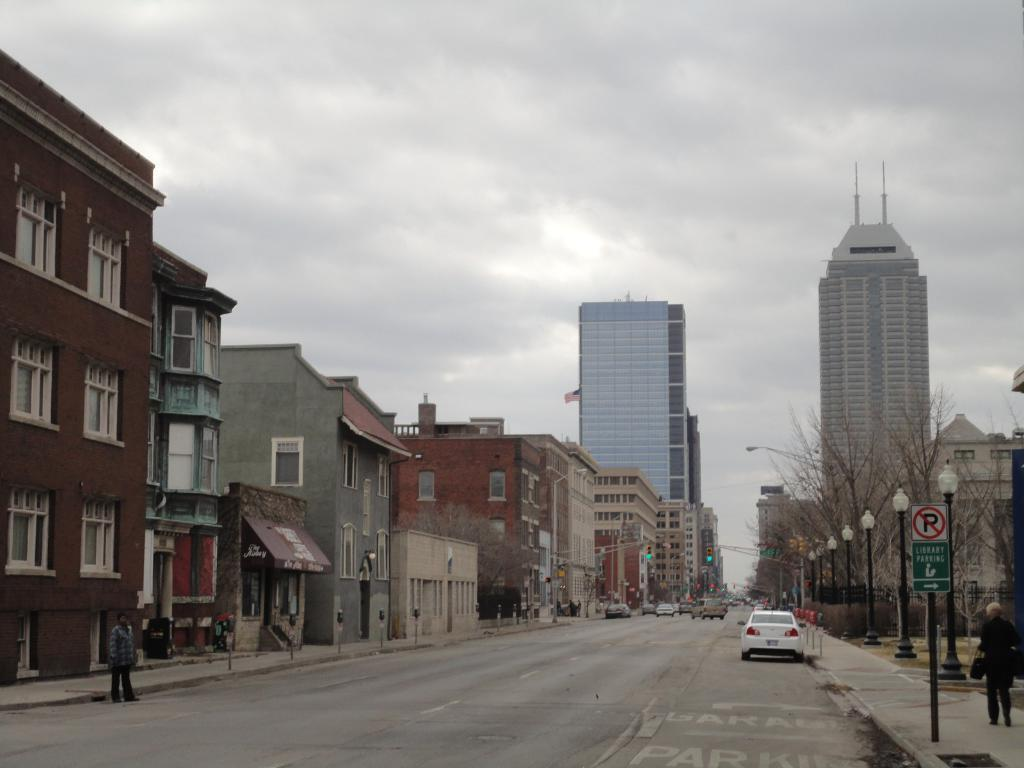What type of natural elements can be seen in the image? There are trees in the image. What type of man-made structures are present in the image? There are light poles, a board, a vehicle, people, a road, buildings, and objects in the image. What is the condition of the sky in the image? The sky is cloudy in the image. What type of transportation is visible on the road in the image? Vehicles are on the road in the image. How many balls are being juggled by the person sitting on the seat in the image? There is no person sitting on a seat or juggling balls in the image. What type of clover is growing near the trees in the image? There is no clover present in the image. 